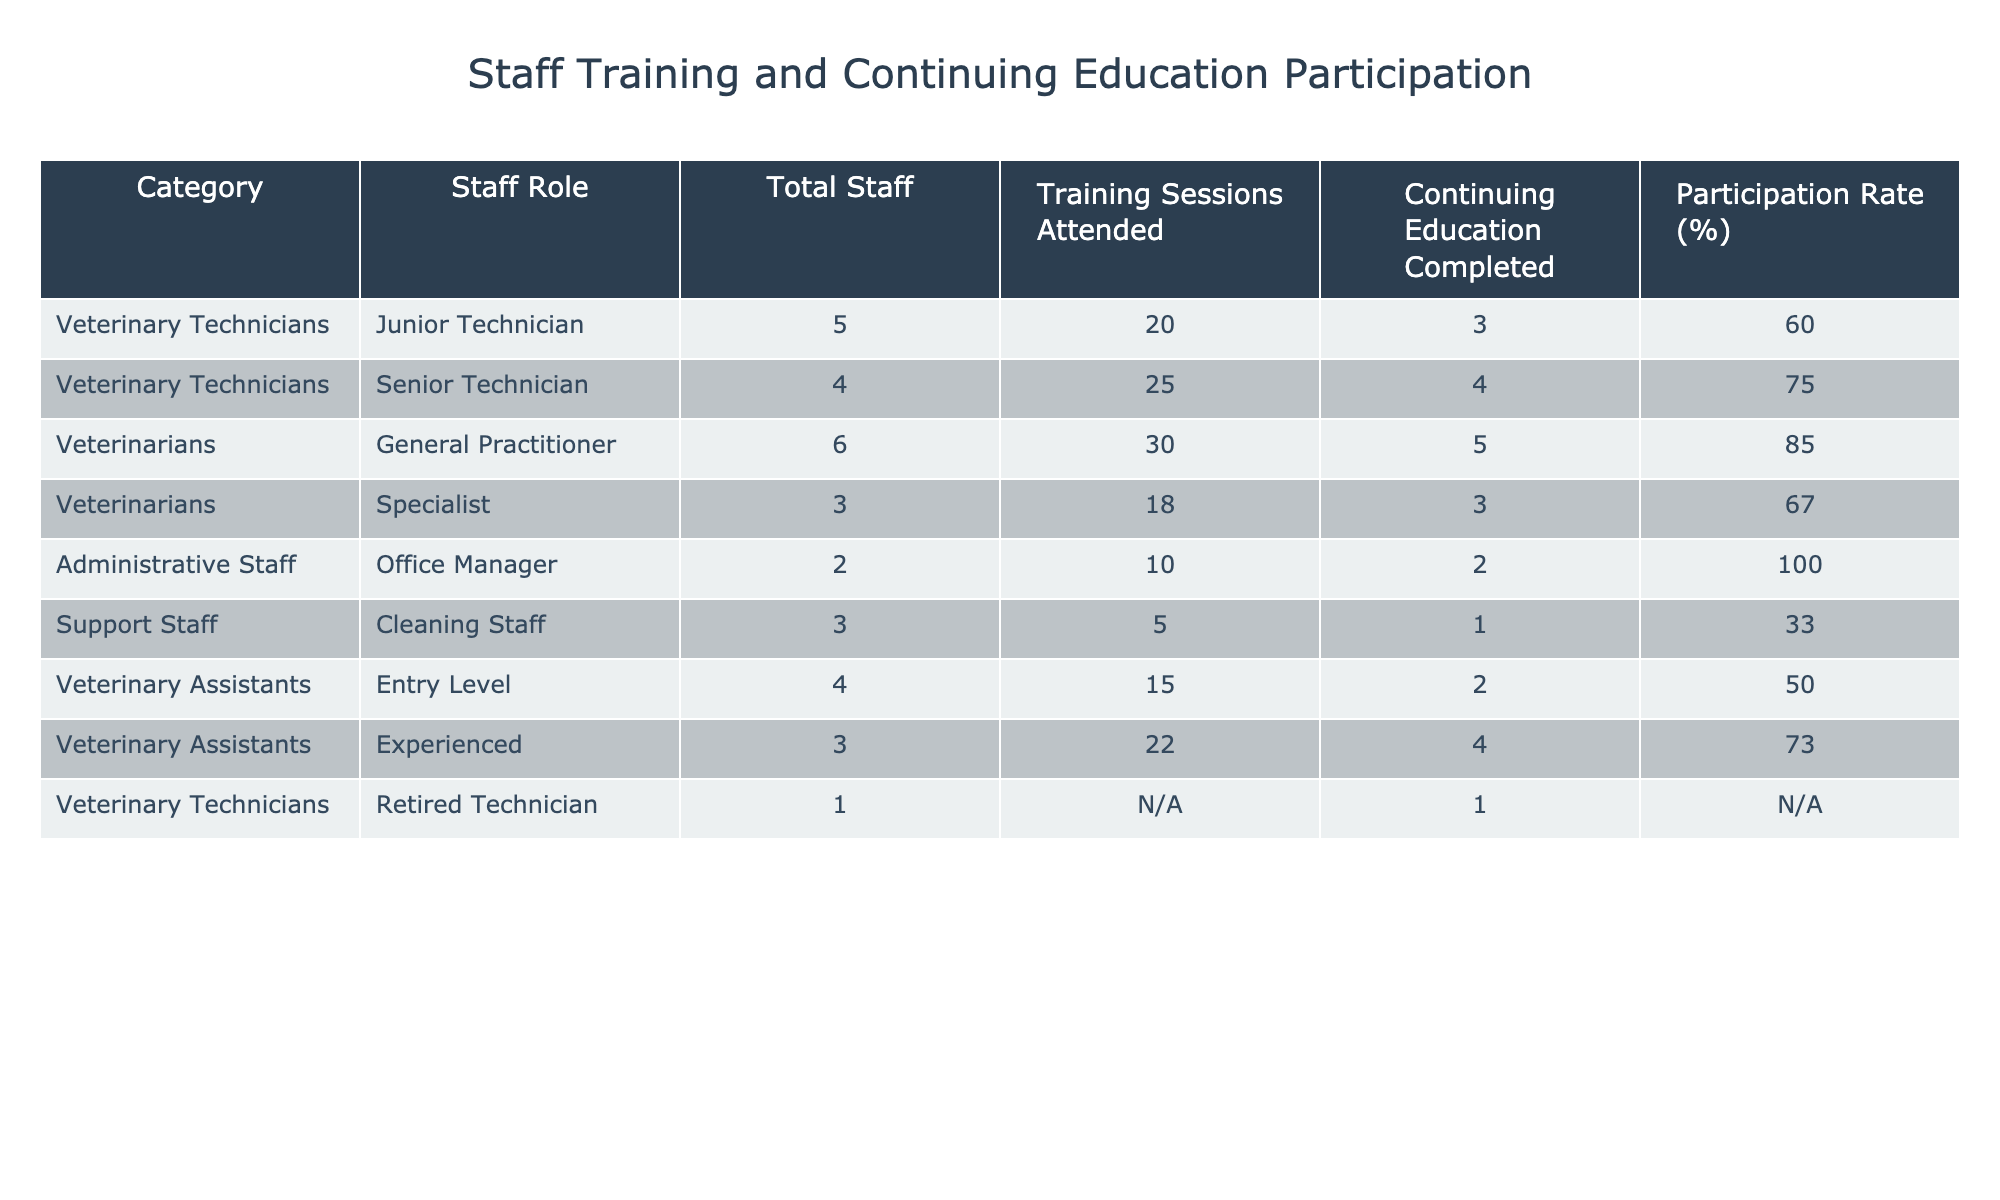What is the participation rate for Senior Technicians? The participation rate for Senior Technicians can be found in the "Participation Rate (%)" column alongside the entry for Senior Technician in the table. It shows 75%.
Answer: 75% How many more training sessions did General Practitioners attend compared to Junior Technicians? To find this, we look at the "Training Sessions Attended" for both roles: General Practitioners attended 30 sessions while Junior Technicians attended 20 sessions. The difference is 30 - 20 = 10.
Answer: 10 Is the participation rate of Office Managers 100%? The participation rate for Office Managers is listed as 100%, thus this statement is true.
Answer: Yes What is the average participation rate of Veterinary Assistants? To find the average participation rate, we first identify the participation rates for both Entry Level (50%) and Experienced (73%) Veterinary Assistants. Adding these rates gives 50 + 73 = 123, and dividing by 2 yields an average of 61.5%.
Answer: 61.5% Which staff role has the highest training sessions attended, and how many sessions did they attend? The table indicates that General Practitioners attended the highest number of training sessions, specifically 30 sessions.
Answer: General Practitioners; 30 How many total staff roles account for a participation rate of less than 60%? We examine the participation rates for all roles. The roles with less than 60% participation are Cleaning Staff (33%) and Junior Technicians (60%). Thus, there are two roles: Cleaning Staff and Veterinary Assistants' Entry Level role.
Answer: 2 What is the difference in the number of Continuing Education completed between General Practitioners and Specialists? From the table, General Practitioners completed 5 Continuing Education sessions and Specialists completed 3 sessions. The difference is 5 - 3 = 2.
Answer: 2 Does the Retired Technician have any recorded training sessions attended? In the table, the entry for Retired Technician shows N/A for training sessions attended, indicating no recorded attendance.
Answer: No What is the total number of training sessions attended by all Administrative Staff? The only Administrative Staff role shown is Office Manager, and they attended 10 training sessions. Therefore, the total is simply 10.
Answer: 10 